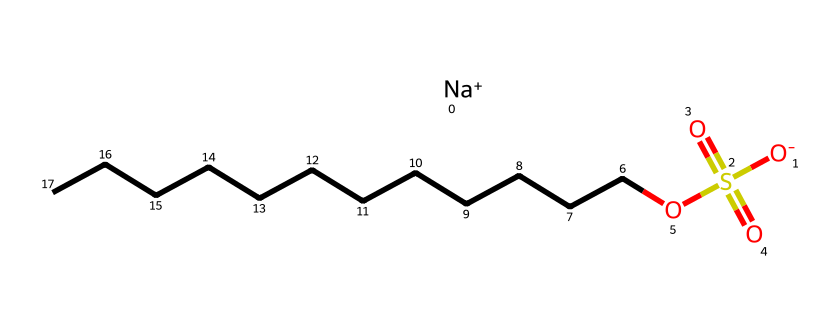What is the total number of carbon atoms in sodium dodecyl sulfate? The SMILES representation shows a straight chain of 12 carbon atoms followed by the sulfate group, which is not counted in the total. Therefore, we can count the 'C' symbols in the long hydrocarbon chain to find there are 12 carbon atoms.
Answer: 12 How many oxygen atoms are present in the molecule? The SMILES notation indicates two sulfonyl oxygen atoms (from the sulfate group) and one hydroxyl oxygen atom, totaling three oxygen atoms. Therefore, counting the 'O's in the structure gives us three oxygen atoms.
Answer: 4 What type of surfactant is sodium dodecyl sulfate? The molecular structure features a hydrophobic hydrocarbon chain and a hydrophilic sulfate group, indicating it is an anionic surfactant. The presence of the negatively charged sulfate group characterizes it as an anionic type.
Answer: anionic What is the charge on the sodium ion in sodium dodecyl sulfate? In the given SMILES, the '[Na+]' clearly indicates a single positive charge associated with the sodium ion, which provides the necessary balance to the overall negative charge of the sulfate part of the molecule.
Answer: +1 How many sulfur atoms are in sodium dodecyl sulfate? The SMILES representation includes only one 'S' symbol, which corresponds to a single sulfur atom. Therefore, we just need to locate 'S' in the notation to count.
Answer: 1 What is the hydrophilic part of sodium dodecyl sulfate? The sulfate group represented in the SMILES as 'S(=O)(=O)O' is the hydrophilic part of the molecule. This area interacts favorably with water due to the presence of negatively charged oxygens, contributing to the surfactant's properties.
Answer: sulfate group 